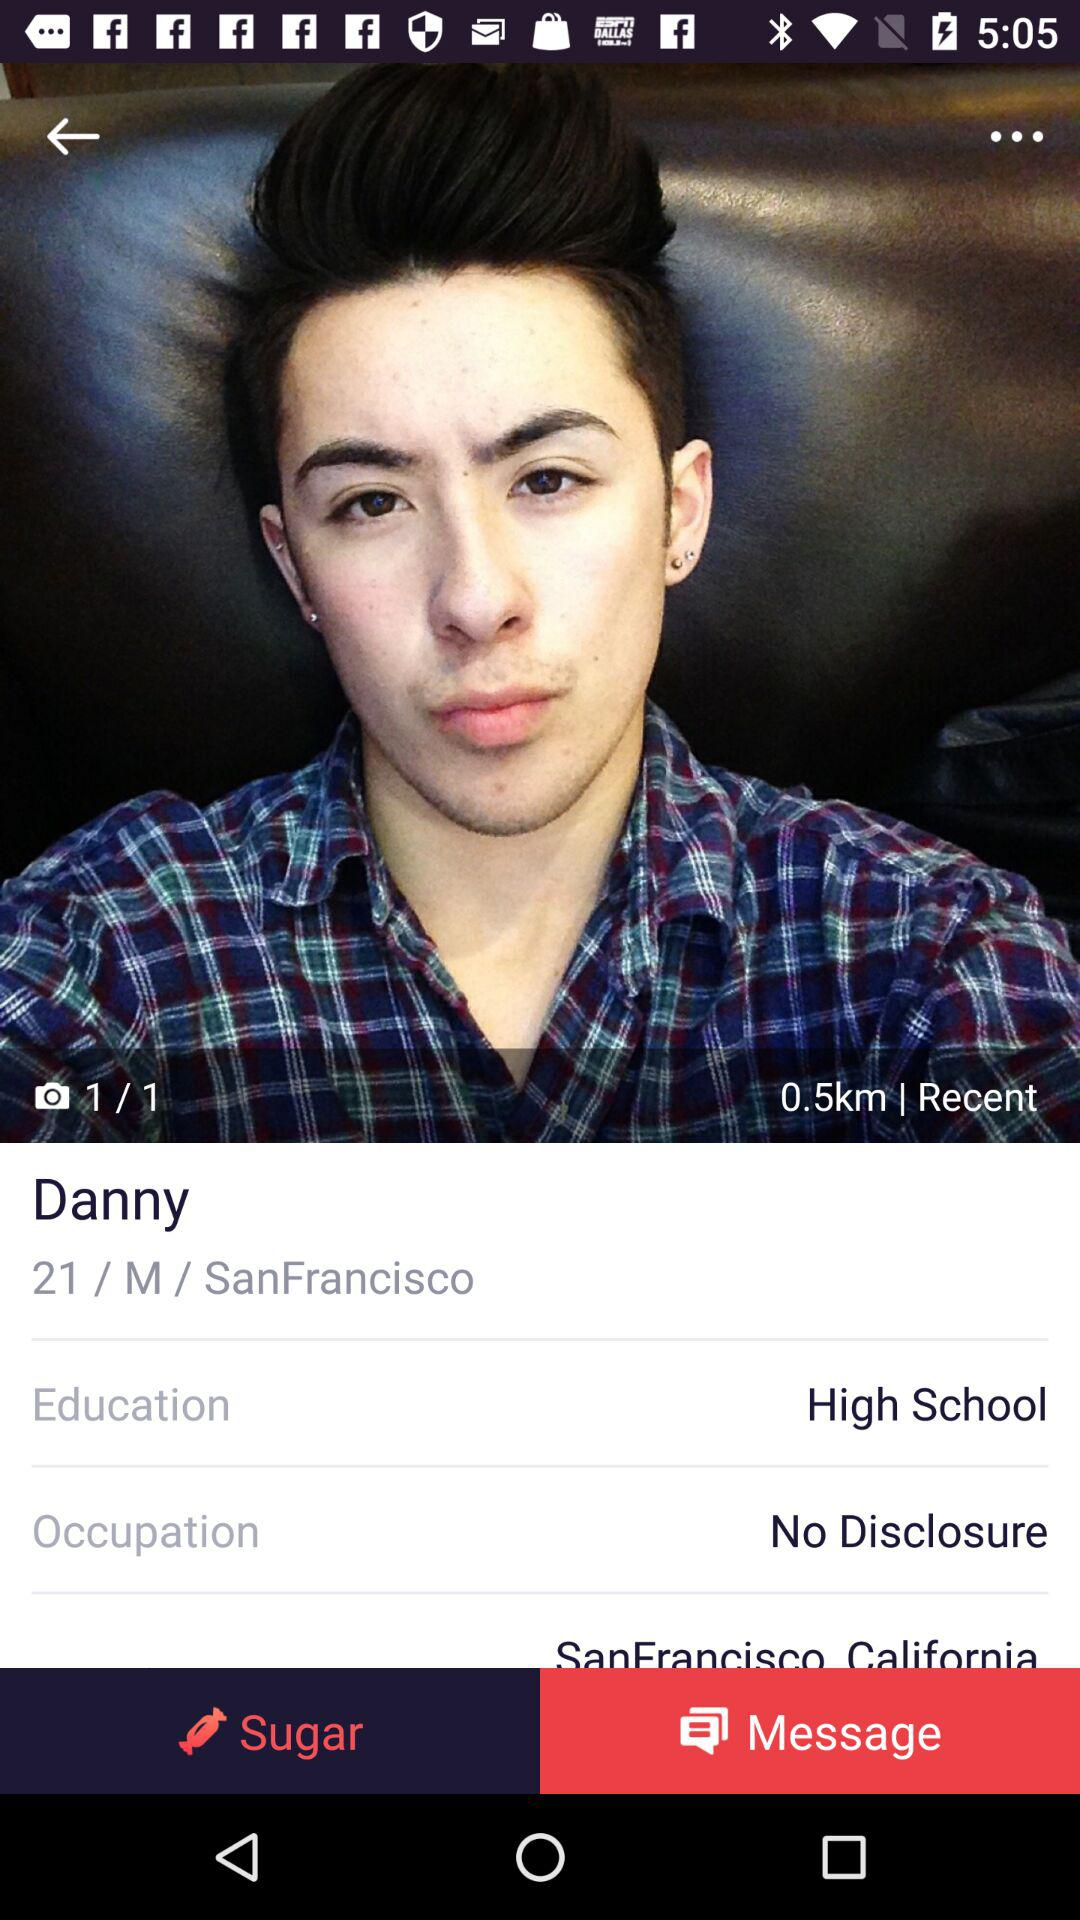What is the occupation of Danny? Danny's occupation is not disclosed. 